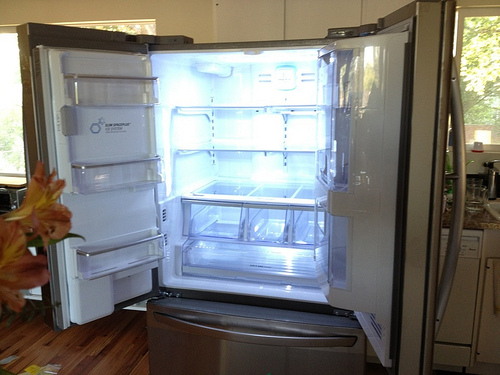Are there any signs of recent use in this kitchen? Yes, the open refrigerator door implies recent activity, and there appear to be fresh lilies on the counter, perhaps recently placed there. What does the presence of the flowers add to the scene? The orange lilies introduce a splash of color and natural beauty, indicating someone's desire to decorate the space and create a cheerful atmosphere. 